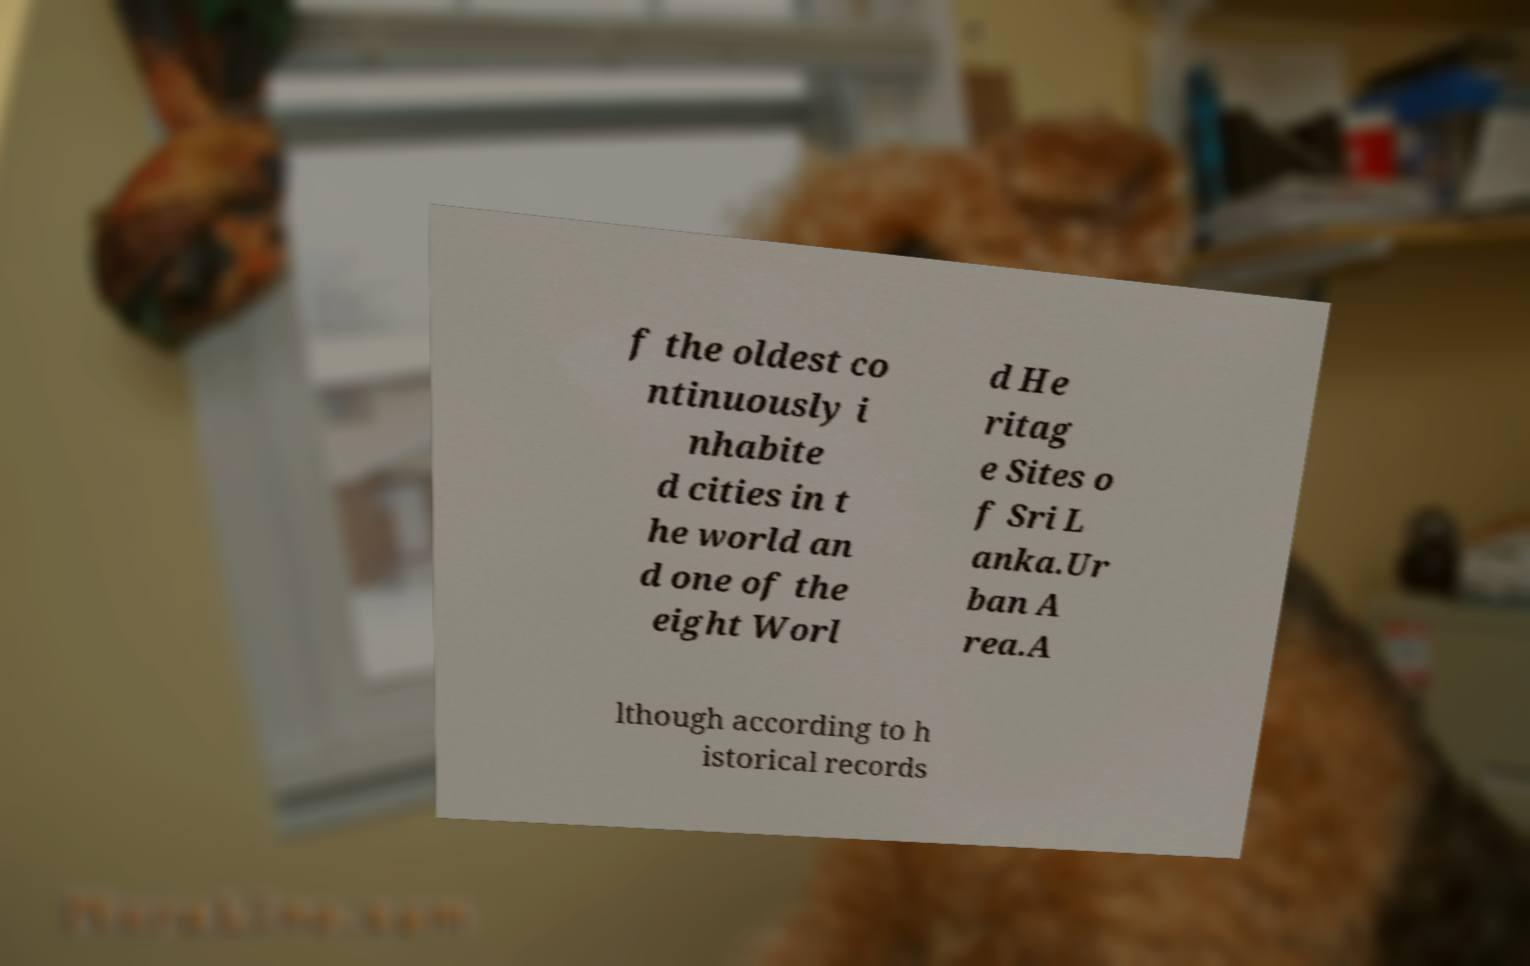Could you extract and type out the text from this image? f the oldest co ntinuously i nhabite d cities in t he world an d one of the eight Worl d He ritag e Sites o f Sri L anka.Ur ban A rea.A lthough according to h istorical records 